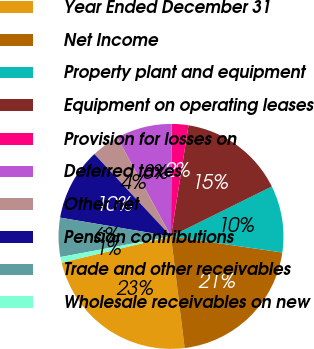Convert chart. <chart><loc_0><loc_0><loc_500><loc_500><pie_chart><fcel>Year Ended December 31<fcel>Net Income<fcel>Property plant and equipment<fcel>Equipment on operating leases<fcel>Provision for losses on<fcel>Deferred taxes<fcel>Other net<fcel>Pension contributions<fcel>Trade and other receivables<fcel>Wholesale receivables on new<nl><fcel>23.18%<fcel>20.78%<fcel>9.6%<fcel>15.19%<fcel>2.41%<fcel>8.0%<fcel>4.01%<fcel>10.4%<fcel>5.61%<fcel>0.81%<nl></chart> 